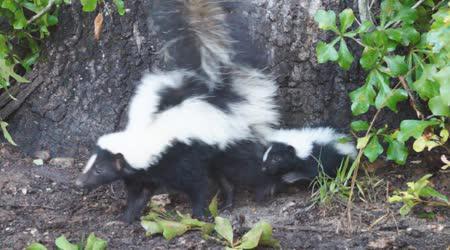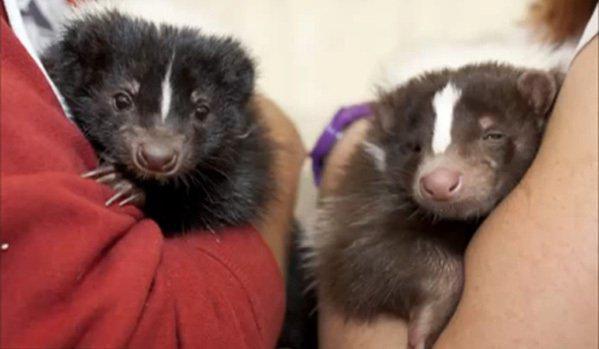The first image is the image on the left, the second image is the image on the right. Analyze the images presented: Is the assertion "The right image shows at least two skunks by the hollow of a fallen log." valid? Answer yes or no. No. 